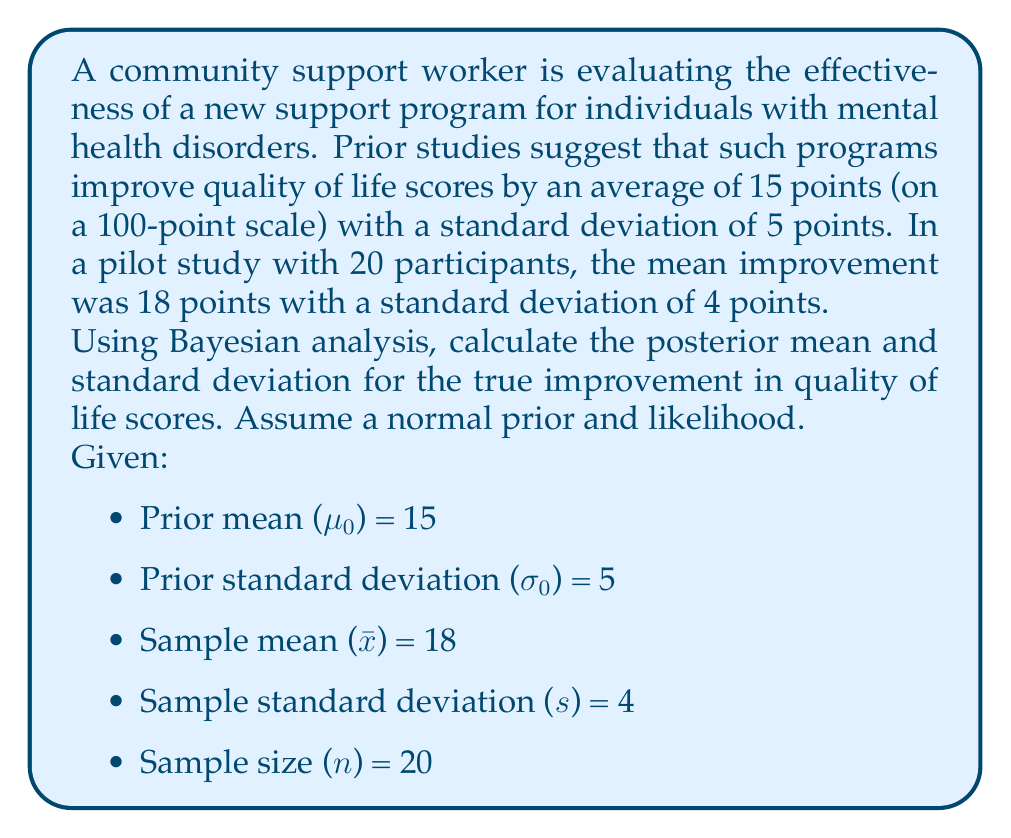Can you solve this math problem? To solve this problem using Bayesian analysis, we'll follow these steps:

1) First, we need to calculate the precision (inverse of variance) for both the prior and the likelihood:

   Prior precision: $τ₀ = \frac{1}{σ₀²} = \frac{1}{5²} = 0.04$
   Likelihood precision: $τ = \frac{n}{s²} = \frac{20}{4²} = 1.25$

2) Now we can calculate the posterior precision:
   $τ_n = τ₀ + τ = 0.04 + 1.25 = 1.29$

3) The posterior mean is a weighted average of the prior mean and the sample mean:

   $μ_n = \frac{τ₀μ₀ + τx̄}{τ_n} = \frac{0.04 \cdot 15 + 1.25 \cdot 18}{1.29} = 17.81$

4) To find the posterior standard deviation, we first calculate the posterior variance:
   
   $σ_n² = \frac{1}{τ_n} = \frac{1}{1.29} = 0.7752$

   Then we take the square root to get the standard deviation:
   
   $σ_n = \sqrt{0.7752} = 0.8804$

Therefore, the posterior distribution for the true improvement in quality of life scores is normal with mean 17.81 and standard deviation 0.8804.
Answer: Posterior mean: 17.81, Posterior standard deviation: 0.8804 